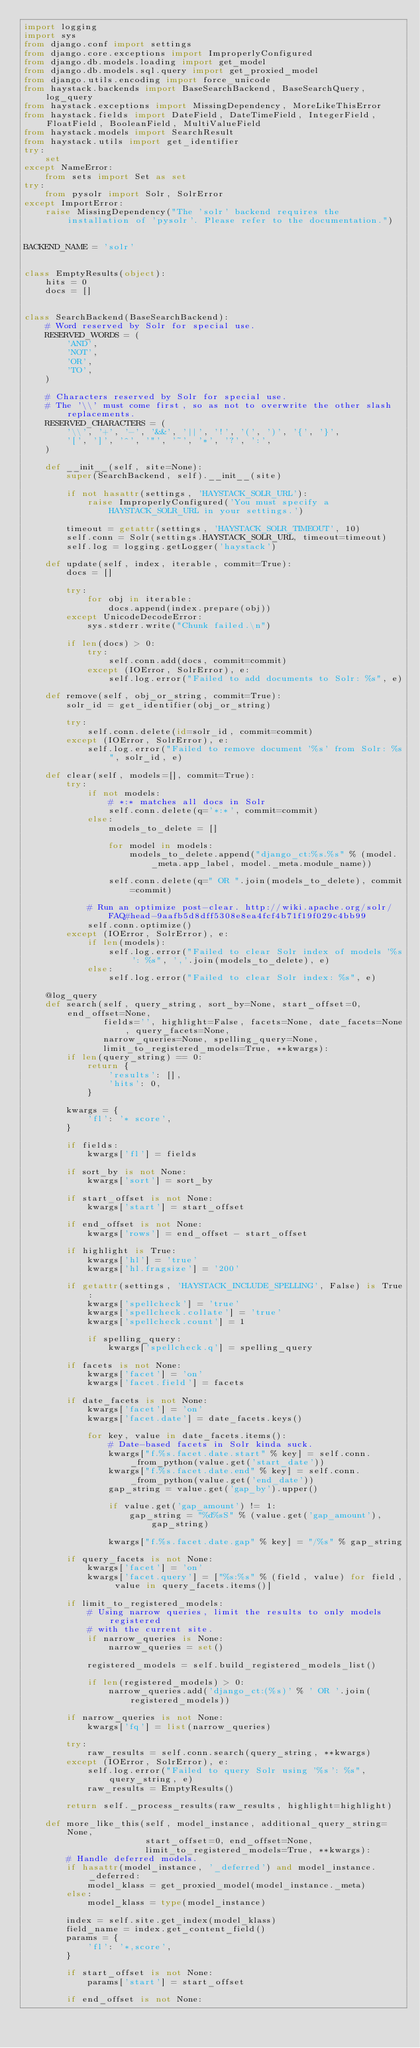<code> <loc_0><loc_0><loc_500><loc_500><_Python_>import logging
import sys
from django.conf import settings
from django.core.exceptions import ImproperlyConfigured
from django.db.models.loading import get_model
from django.db.models.sql.query import get_proxied_model
from django.utils.encoding import force_unicode
from haystack.backends import BaseSearchBackend, BaseSearchQuery, log_query
from haystack.exceptions import MissingDependency, MoreLikeThisError
from haystack.fields import DateField, DateTimeField, IntegerField, FloatField, BooleanField, MultiValueField
from haystack.models import SearchResult
from haystack.utils import get_identifier
try:
    set
except NameError:
    from sets import Set as set
try:
    from pysolr import Solr, SolrError
except ImportError:
    raise MissingDependency("The 'solr' backend requires the installation of 'pysolr'. Please refer to the documentation.")


BACKEND_NAME = 'solr'


class EmptyResults(object):
    hits = 0
    docs = []


class SearchBackend(BaseSearchBackend):
    # Word reserved by Solr for special use.
    RESERVED_WORDS = (
        'AND',
        'NOT',
        'OR',
        'TO',
    )
    
    # Characters reserved by Solr for special use.
    # The '\\' must come first, so as not to overwrite the other slash replacements.
    RESERVED_CHARACTERS = (
        '\\', '+', '-', '&&', '||', '!', '(', ')', '{', '}',
        '[', ']', '^', '"', '~', '*', '?', ':',
    )
    
    def __init__(self, site=None):
        super(SearchBackend, self).__init__(site)
        
        if not hasattr(settings, 'HAYSTACK_SOLR_URL'):
            raise ImproperlyConfigured('You must specify a HAYSTACK_SOLR_URL in your settings.')
        
        timeout = getattr(settings, 'HAYSTACK_SOLR_TIMEOUT', 10)
        self.conn = Solr(settings.HAYSTACK_SOLR_URL, timeout=timeout)
        self.log = logging.getLogger('haystack')
    
    def update(self, index, iterable, commit=True):
        docs = []
        
        try:
            for obj in iterable:
                docs.append(index.prepare(obj))
        except UnicodeDecodeError:
            sys.stderr.write("Chunk failed.\n")
        
        if len(docs) > 0:
            try:
                self.conn.add(docs, commit=commit)
            except (IOError, SolrError), e:
                self.log.error("Failed to add documents to Solr: %s", e)
    
    def remove(self, obj_or_string, commit=True):
        solr_id = get_identifier(obj_or_string)
        
        try:
            self.conn.delete(id=solr_id, commit=commit)
        except (IOError, SolrError), e:
            self.log.error("Failed to remove document '%s' from Solr: %s", solr_id, e)
    
    def clear(self, models=[], commit=True):
        try:
            if not models:
                # *:* matches all docs in Solr
                self.conn.delete(q='*:*', commit=commit)
            else:
                models_to_delete = []
                
                for model in models:
                    models_to_delete.append("django_ct:%s.%s" % (model._meta.app_label, model._meta.module_name))
                
                self.conn.delete(q=" OR ".join(models_to_delete), commit=commit)
            
            # Run an optimize post-clear. http://wiki.apache.org/solr/FAQ#head-9aafb5d8dff5308e8ea4fcf4b71f19f029c4bb99
            self.conn.optimize()
        except (IOError, SolrError), e:
            if len(models):
                self.log.error("Failed to clear Solr index of models '%s': %s", ','.join(models_to_delete), e)
            else:
                self.log.error("Failed to clear Solr index: %s", e)
    
    @log_query
    def search(self, query_string, sort_by=None, start_offset=0, end_offset=None,
               fields='', highlight=False, facets=None, date_facets=None, query_facets=None,
               narrow_queries=None, spelling_query=None,
               limit_to_registered_models=True, **kwargs):
        if len(query_string) == 0:
            return {
                'results': [],
                'hits': 0,
            }
        
        kwargs = {
            'fl': '* score',
        }
        
        if fields:
            kwargs['fl'] = fields
        
        if sort_by is not None:
            kwargs['sort'] = sort_by
        
        if start_offset is not None:
            kwargs['start'] = start_offset
        
        if end_offset is not None:
            kwargs['rows'] = end_offset - start_offset
        
        if highlight is True:
            kwargs['hl'] = 'true'
            kwargs['hl.fragsize'] = '200'
        
        if getattr(settings, 'HAYSTACK_INCLUDE_SPELLING', False) is True:
            kwargs['spellcheck'] = 'true'
            kwargs['spellcheck.collate'] = 'true'
            kwargs['spellcheck.count'] = 1
            
            if spelling_query:
                kwargs['spellcheck.q'] = spelling_query
        
        if facets is not None:
            kwargs['facet'] = 'on'
            kwargs['facet.field'] = facets
        
        if date_facets is not None:
            kwargs['facet'] = 'on'
            kwargs['facet.date'] = date_facets.keys()
            
            for key, value in date_facets.items():
                # Date-based facets in Solr kinda suck.
                kwargs["f.%s.facet.date.start" % key] = self.conn._from_python(value.get('start_date'))
                kwargs["f.%s.facet.date.end" % key] = self.conn._from_python(value.get('end_date'))
                gap_string = value.get('gap_by').upper()
                
                if value.get('gap_amount') != 1:
                    gap_string = "%d%sS" % (value.get('gap_amount'), gap_string)
                
                kwargs["f.%s.facet.date.gap" % key] = "/%s" % gap_string
        
        if query_facets is not None:
            kwargs['facet'] = 'on'
            kwargs['facet.query'] = ["%s:%s" % (field, value) for field, value in query_facets.items()]
        
        if limit_to_registered_models:
            # Using narrow queries, limit the results to only models registered
            # with the current site.
            if narrow_queries is None:
                narrow_queries = set()
            
            registered_models = self.build_registered_models_list()
            
            if len(registered_models) > 0:
                narrow_queries.add('django_ct:(%s)' % ' OR '.join(registered_models))
        
        if narrow_queries is not None:
            kwargs['fq'] = list(narrow_queries)
        
        try:
            raw_results = self.conn.search(query_string, **kwargs)
        except (IOError, SolrError), e:
            self.log.error("Failed to query Solr using '%s': %s", query_string, e)
            raw_results = EmptyResults()
        
        return self._process_results(raw_results, highlight=highlight)
    
    def more_like_this(self, model_instance, additional_query_string=None,
                       start_offset=0, end_offset=None,
                       limit_to_registered_models=True, **kwargs):
        # Handle deferred models.
        if hasattr(model_instance, '_deferred') and model_instance._deferred:
            model_klass = get_proxied_model(model_instance._meta)
        else:
            model_klass = type(model_instance)
        
        index = self.site.get_index(model_klass)
        field_name = index.get_content_field()
        params = {
            'fl': '*,score',
        }
        
        if start_offset is not None:
            params['start'] = start_offset
        
        if end_offset is not None:</code> 